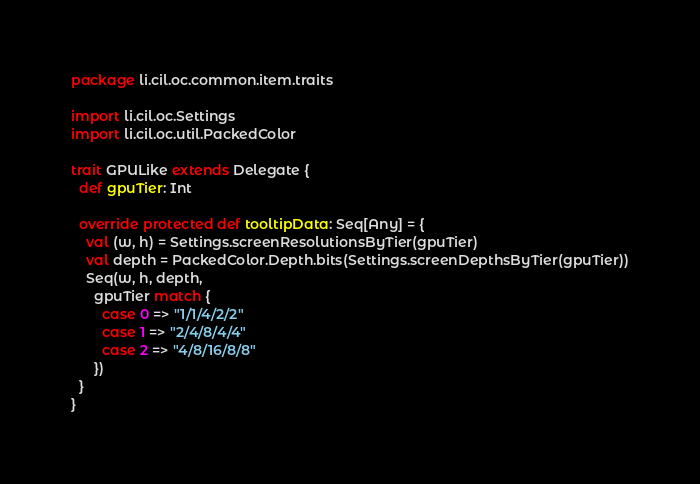<code> <loc_0><loc_0><loc_500><loc_500><_Scala_>package li.cil.oc.common.item.traits

import li.cil.oc.Settings
import li.cil.oc.util.PackedColor

trait GPULike extends Delegate {
  def gpuTier: Int

  override protected def tooltipData: Seq[Any] = {
    val (w, h) = Settings.screenResolutionsByTier(gpuTier)
    val depth = PackedColor.Depth.bits(Settings.screenDepthsByTier(gpuTier))
    Seq(w, h, depth,
      gpuTier match {
        case 0 => "1/1/4/2/2"
        case 1 => "2/4/8/4/4"
        case 2 => "4/8/16/8/8"
      })
  }
}
</code> 